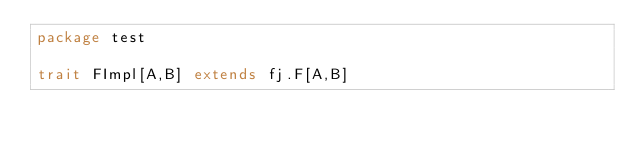Convert code to text. <code><loc_0><loc_0><loc_500><loc_500><_Scala_>package test

trait FImpl[A,B] extends fj.F[A,B]</code> 